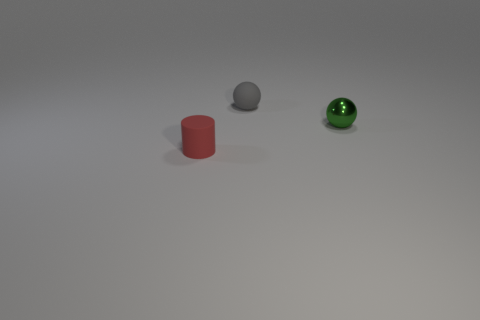How many metallic objects are cyan things or tiny red cylinders?
Your answer should be very brief. 0. There is a small rubber object that is in front of the small gray rubber ball; how many rubber things are behind it?
Ensure brevity in your answer.  1. What number of objects are large yellow shiny spheres or matte cylinders on the left side of the small matte sphere?
Offer a very short reply. 1. Is there a small gray object that has the same material as the red object?
Your answer should be very brief. Yes. What number of tiny things are both to the left of the metal ball and behind the red object?
Keep it short and to the point. 1. What is the material of the thing that is to the right of the gray matte object?
Make the answer very short. Metal. Are there any tiny rubber spheres in front of the tiny matte sphere?
Your answer should be compact. No. The other object that is the same shape as the gray object is what size?
Offer a terse response. Small. Does the matte cylinder have the same color as the rubber ball?
Your answer should be compact. No. Are there fewer big green matte balls than small green balls?
Give a very brief answer. Yes. 